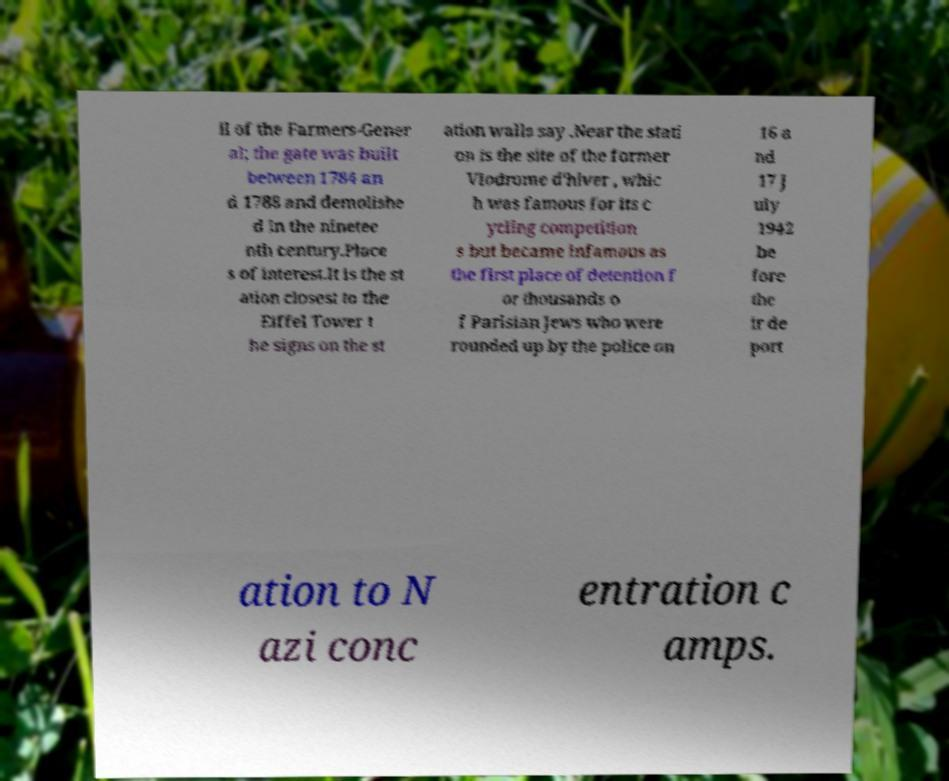Can you accurately transcribe the text from the provided image for me? ll of the Farmers-Gener al; the gate was built between 1784 an d 1788 and demolishe d in the ninetee nth century.Place s of interest.It is the st ation closest to the Eiffel Tower t he signs on the st ation walls say .Near the stati on is the site of the former Vlodrome d'hiver , whic h was famous for its c ycling competition s but became infamous as the first place of detention f or thousands o f Parisian Jews who were rounded up by the police on 16 a nd 17 J uly 1942 be fore the ir de port ation to N azi conc entration c amps. 